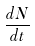Convert formula to latex. <formula><loc_0><loc_0><loc_500><loc_500>\frac { d N } { d t }</formula> 